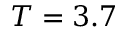<formula> <loc_0><loc_0><loc_500><loc_500>T = 3 . 7</formula> 